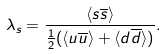Convert formula to latex. <formula><loc_0><loc_0><loc_500><loc_500>\lambda _ { s } = \frac { \langle s \overline { s } \rangle } { \frac { 1 } { 2 } ( \langle u \overline { u } \rangle + \langle d \overline { d } \rangle ) } .</formula> 